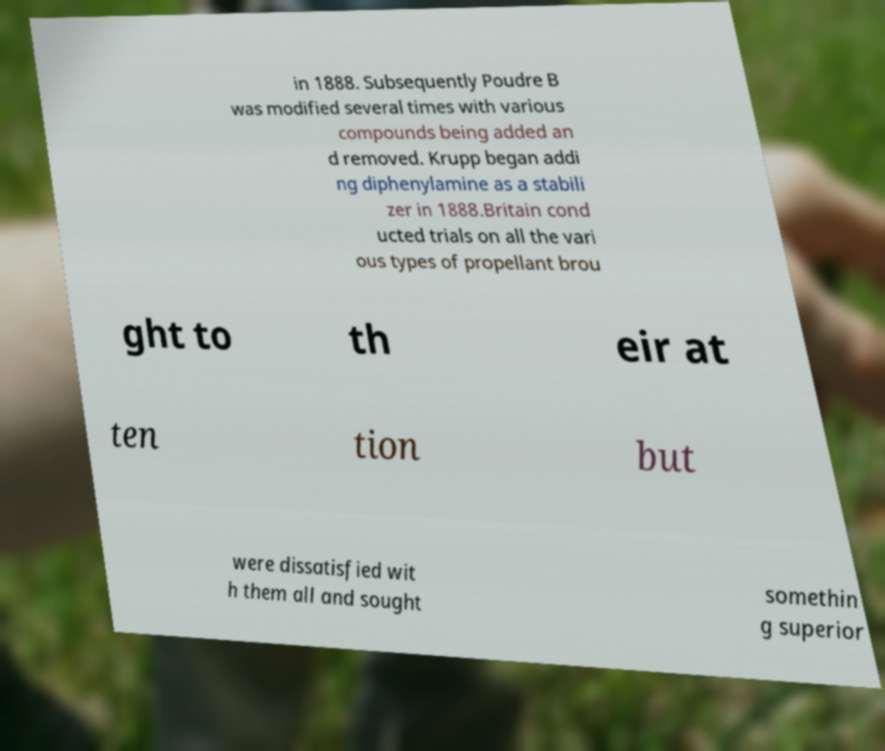Could you assist in decoding the text presented in this image and type it out clearly? in 1888. Subsequently Poudre B was modified several times with various compounds being added an d removed. Krupp began addi ng diphenylamine as a stabili zer in 1888.Britain cond ucted trials on all the vari ous types of propellant brou ght to th eir at ten tion but were dissatisfied wit h them all and sought somethin g superior 